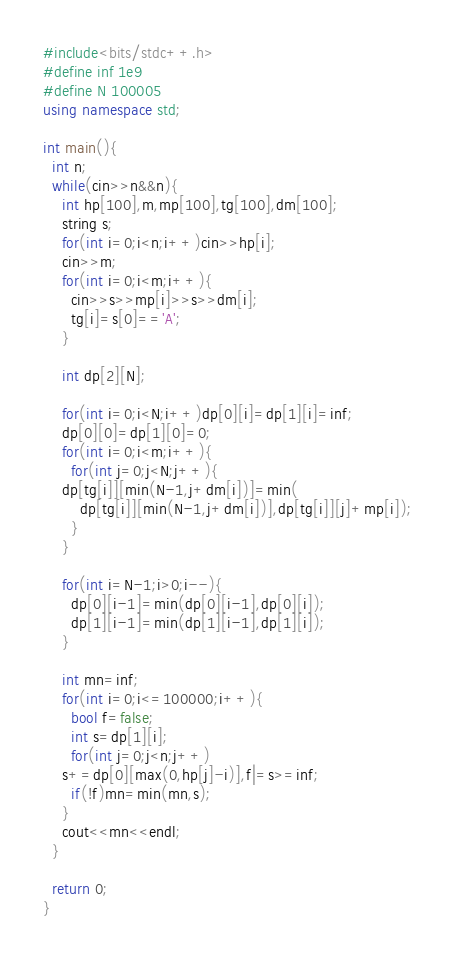<code> <loc_0><loc_0><loc_500><loc_500><_C++_>#include<bits/stdc++.h>
#define inf 1e9
#define N 100005
using namespace std;

int main(){
  int n;
  while(cin>>n&&n){
    int hp[100],m,mp[100],tg[100],dm[100];
    string s;
    for(int i=0;i<n;i++)cin>>hp[i];
    cin>>m;
    for(int i=0;i<m;i++){
      cin>>s>>mp[i]>>s>>dm[i];
      tg[i]=s[0]=='A';
    }

    int dp[2][N];

    for(int i=0;i<N;i++)dp[0][i]=dp[1][i]=inf;
    dp[0][0]=dp[1][0]=0;
    for(int i=0;i<m;i++){
      for(int j=0;j<N;j++){
	dp[tg[i]][min(N-1,j+dm[i])]=min(
        dp[tg[i]][min(N-1,j+dm[i])],dp[tg[i]][j]+mp[i]);
      }
    }

    for(int i=N-1;i>0;i--){
      dp[0][i-1]=min(dp[0][i-1],dp[0][i]);
      dp[1][i-1]=min(dp[1][i-1],dp[1][i]);
    }

    int mn=inf;
    for(int i=0;i<=100000;i++){
      bool f=false;
      int s=dp[1][i];
      for(int j=0;j<n;j++)
	s+=dp[0][max(0,hp[j]-i)],f|=s>=inf;
      if(!f)mn=min(mn,s);
    }
    cout<<mn<<endl;
  }

  return 0;
}</code> 